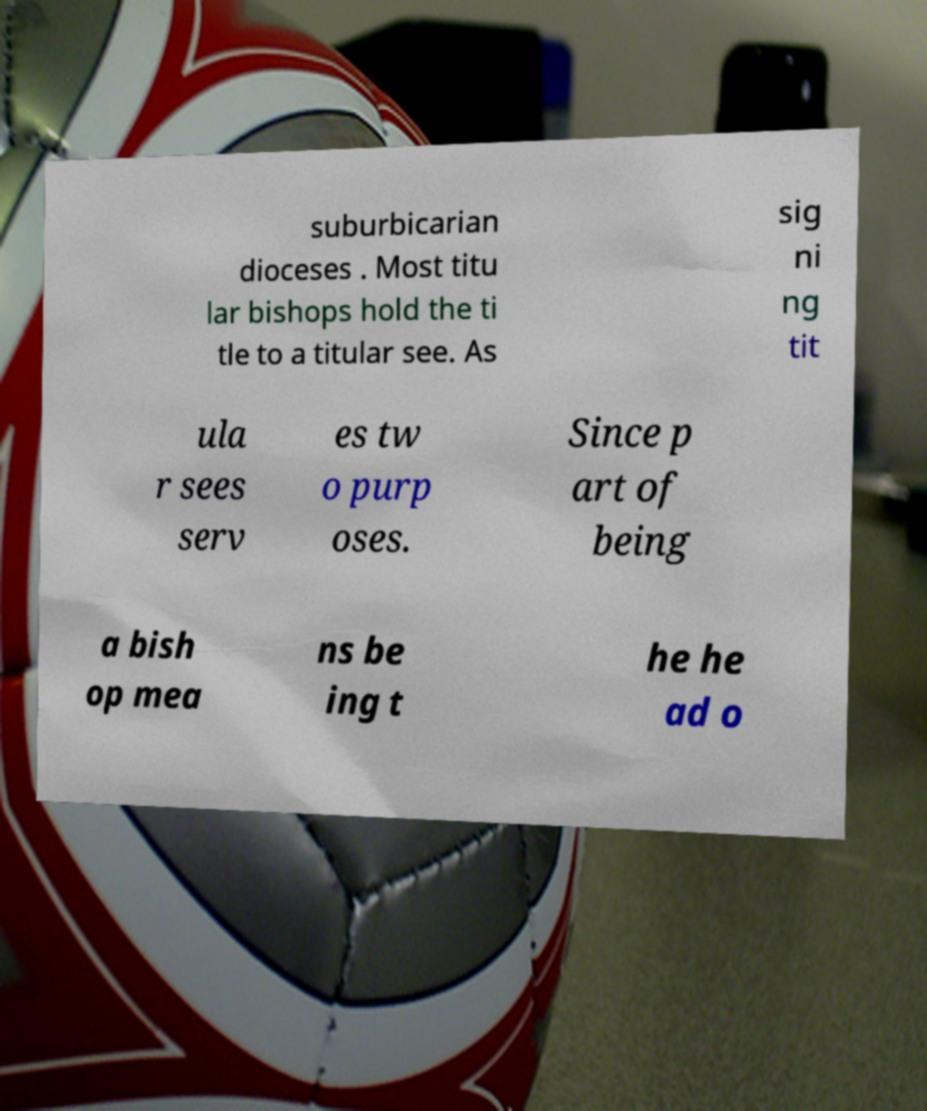There's text embedded in this image that I need extracted. Can you transcribe it verbatim? suburbicarian dioceses . Most titu lar bishops hold the ti tle to a titular see. As sig ni ng tit ula r sees serv es tw o purp oses. Since p art of being a bish op mea ns be ing t he he ad o 